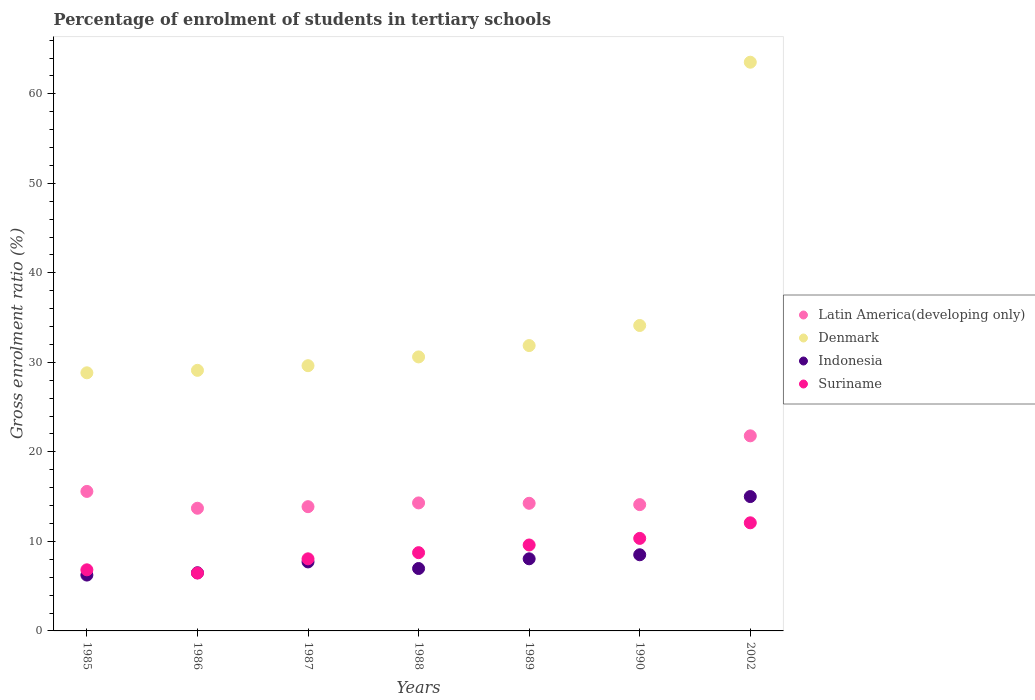Is the number of dotlines equal to the number of legend labels?
Offer a very short reply. Yes. What is the percentage of students enrolled in tertiary schools in Indonesia in 1989?
Provide a succinct answer. 8.06. Across all years, what is the maximum percentage of students enrolled in tertiary schools in Latin America(developing only)?
Your answer should be very brief. 21.8. Across all years, what is the minimum percentage of students enrolled in tertiary schools in Latin America(developing only)?
Your response must be concise. 13.71. What is the total percentage of students enrolled in tertiary schools in Indonesia in the graph?
Provide a short and direct response. 58.99. What is the difference between the percentage of students enrolled in tertiary schools in Suriname in 1986 and that in 1989?
Make the answer very short. -3.13. What is the difference between the percentage of students enrolled in tertiary schools in Denmark in 1989 and the percentage of students enrolled in tertiary schools in Suriname in 1986?
Provide a short and direct response. 25.41. What is the average percentage of students enrolled in tertiary schools in Latin America(developing only) per year?
Provide a succinct answer. 15.38. In the year 1985, what is the difference between the percentage of students enrolled in tertiary schools in Suriname and percentage of students enrolled in tertiary schools in Latin America(developing only)?
Keep it short and to the point. -8.76. In how many years, is the percentage of students enrolled in tertiary schools in Latin America(developing only) greater than 8 %?
Make the answer very short. 7. What is the ratio of the percentage of students enrolled in tertiary schools in Latin America(developing only) in 1987 to that in 1990?
Offer a very short reply. 0.98. Is the percentage of students enrolled in tertiary schools in Denmark in 1987 less than that in 1988?
Your response must be concise. Yes. Is the difference between the percentage of students enrolled in tertiary schools in Suriname in 1987 and 1989 greater than the difference between the percentage of students enrolled in tertiary schools in Latin America(developing only) in 1987 and 1989?
Your response must be concise. No. What is the difference between the highest and the second highest percentage of students enrolled in tertiary schools in Denmark?
Your answer should be compact. 29.41. What is the difference between the highest and the lowest percentage of students enrolled in tertiary schools in Suriname?
Make the answer very short. 5.61. In how many years, is the percentage of students enrolled in tertiary schools in Indonesia greater than the average percentage of students enrolled in tertiary schools in Indonesia taken over all years?
Your response must be concise. 2. Is the sum of the percentage of students enrolled in tertiary schools in Suriname in 1987 and 2002 greater than the maximum percentage of students enrolled in tertiary schools in Denmark across all years?
Provide a succinct answer. No. How many dotlines are there?
Offer a very short reply. 4. Does the graph contain any zero values?
Give a very brief answer. No. Does the graph contain grids?
Offer a terse response. No. How are the legend labels stacked?
Give a very brief answer. Vertical. What is the title of the graph?
Provide a short and direct response. Percentage of enrolment of students in tertiary schools. Does "Palau" appear as one of the legend labels in the graph?
Provide a short and direct response. No. What is the label or title of the X-axis?
Your answer should be very brief. Years. What is the Gross enrolment ratio (%) in Latin America(developing only) in 1985?
Keep it short and to the point. 15.59. What is the Gross enrolment ratio (%) of Denmark in 1985?
Make the answer very short. 28.84. What is the Gross enrolment ratio (%) of Indonesia in 1985?
Make the answer very short. 6.24. What is the Gross enrolment ratio (%) of Suriname in 1985?
Provide a short and direct response. 6.83. What is the Gross enrolment ratio (%) of Latin America(developing only) in 1986?
Offer a very short reply. 13.71. What is the Gross enrolment ratio (%) in Denmark in 1986?
Offer a terse response. 29.11. What is the Gross enrolment ratio (%) in Indonesia in 1986?
Offer a terse response. 6.5. What is the Gross enrolment ratio (%) of Suriname in 1986?
Your answer should be very brief. 6.47. What is the Gross enrolment ratio (%) in Latin America(developing only) in 1987?
Provide a short and direct response. 13.88. What is the Gross enrolment ratio (%) in Denmark in 1987?
Your answer should be compact. 29.63. What is the Gross enrolment ratio (%) in Indonesia in 1987?
Your answer should be compact. 7.71. What is the Gross enrolment ratio (%) of Suriname in 1987?
Your answer should be very brief. 8.05. What is the Gross enrolment ratio (%) in Latin America(developing only) in 1988?
Make the answer very short. 14.3. What is the Gross enrolment ratio (%) in Denmark in 1988?
Make the answer very short. 30.61. What is the Gross enrolment ratio (%) of Indonesia in 1988?
Offer a very short reply. 6.97. What is the Gross enrolment ratio (%) in Suriname in 1988?
Your answer should be very brief. 8.74. What is the Gross enrolment ratio (%) in Latin America(developing only) in 1989?
Provide a succinct answer. 14.26. What is the Gross enrolment ratio (%) of Denmark in 1989?
Make the answer very short. 31.88. What is the Gross enrolment ratio (%) in Indonesia in 1989?
Offer a very short reply. 8.06. What is the Gross enrolment ratio (%) in Suriname in 1989?
Ensure brevity in your answer.  9.6. What is the Gross enrolment ratio (%) of Latin America(developing only) in 1990?
Give a very brief answer. 14.11. What is the Gross enrolment ratio (%) in Denmark in 1990?
Offer a very short reply. 34.12. What is the Gross enrolment ratio (%) of Indonesia in 1990?
Your answer should be very brief. 8.51. What is the Gross enrolment ratio (%) in Suriname in 1990?
Provide a short and direct response. 10.34. What is the Gross enrolment ratio (%) in Latin America(developing only) in 2002?
Your answer should be very brief. 21.8. What is the Gross enrolment ratio (%) in Denmark in 2002?
Your answer should be very brief. 63.54. What is the Gross enrolment ratio (%) of Indonesia in 2002?
Your answer should be compact. 15.01. What is the Gross enrolment ratio (%) in Suriname in 2002?
Offer a terse response. 12.08. Across all years, what is the maximum Gross enrolment ratio (%) of Latin America(developing only)?
Your answer should be very brief. 21.8. Across all years, what is the maximum Gross enrolment ratio (%) in Denmark?
Your response must be concise. 63.54. Across all years, what is the maximum Gross enrolment ratio (%) of Indonesia?
Make the answer very short. 15.01. Across all years, what is the maximum Gross enrolment ratio (%) of Suriname?
Your response must be concise. 12.08. Across all years, what is the minimum Gross enrolment ratio (%) in Latin America(developing only)?
Offer a terse response. 13.71. Across all years, what is the minimum Gross enrolment ratio (%) of Denmark?
Your response must be concise. 28.84. Across all years, what is the minimum Gross enrolment ratio (%) of Indonesia?
Your answer should be very brief. 6.24. Across all years, what is the minimum Gross enrolment ratio (%) in Suriname?
Make the answer very short. 6.47. What is the total Gross enrolment ratio (%) of Latin America(developing only) in the graph?
Make the answer very short. 107.64. What is the total Gross enrolment ratio (%) in Denmark in the graph?
Your answer should be very brief. 247.73. What is the total Gross enrolment ratio (%) of Indonesia in the graph?
Your response must be concise. 58.99. What is the total Gross enrolment ratio (%) of Suriname in the graph?
Give a very brief answer. 62.11. What is the difference between the Gross enrolment ratio (%) of Latin America(developing only) in 1985 and that in 1986?
Provide a short and direct response. 1.88. What is the difference between the Gross enrolment ratio (%) in Denmark in 1985 and that in 1986?
Your response must be concise. -0.28. What is the difference between the Gross enrolment ratio (%) in Indonesia in 1985 and that in 1986?
Provide a succinct answer. -0.26. What is the difference between the Gross enrolment ratio (%) of Suriname in 1985 and that in 1986?
Your answer should be very brief. 0.36. What is the difference between the Gross enrolment ratio (%) in Latin America(developing only) in 1985 and that in 1987?
Ensure brevity in your answer.  1.71. What is the difference between the Gross enrolment ratio (%) of Denmark in 1985 and that in 1987?
Your answer should be very brief. -0.8. What is the difference between the Gross enrolment ratio (%) of Indonesia in 1985 and that in 1987?
Your response must be concise. -1.47. What is the difference between the Gross enrolment ratio (%) in Suriname in 1985 and that in 1987?
Make the answer very short. -1.23. What is the difference between the Gross enrolment ratio (%) in Latin America(developing only) in 1985 and that in 1988?
Keep it short and to the point. 1.28. What is the difference between the Gross enrolment ratio (%) in Denmark in 1985 and that in 1988?
Provide a succinct answer. -1.78. What is the difference between the Gross enrolment ratio (%) in Indonesia in 1985 and that in 1988?
Provide a succinct answer. -0.73. What is the difference between the Gross enrolment ratio (%) in Suriname in 1985 and that in 1988?
Make the answer very short. -1.92. What is the difference between the Gross enrolment ratio (%) of Latin America(developing only) in 1985 and that in 1989?
Make the answer very short. 1.33. What is the difference between the Gross enrolment ratio (%) of Denmark in 1985 and that in 1989?
Provide a short and direct response. -3.04. What is the difference between the Gross enrolment ratio (%) in Indonesia in 1985 and that in 1989?
Offer a terse response. -1.82. What is the difference between the Gross enrolment ratio (%) of Suriname in 1985 and that in 1989?
Ensure brevity in your answer.  -2.77. What is the difference between the Gross enrolment ratio (%) in Latin America(developing only) in 1985 and that in 1990?
Give a very brief answer. 1.48. What is the difference between the Gross enrolment ratio (%) of Denmark in 1985 and that in 1990?
Keep it short and to the point. -5.29. What is the difference between the Gross enrolment ratio (%) of Indonesia in 1985 and that in 1990?
Ensure brevity in your answer.  -2.27. What is the difference between the Gross enrolment ratio (%) of Suriname in 1985 and that in 1990?
Offer a very short reply. -3.51. What is the difference between the Gross enrolment ratio (%) of Latin America(developing only) in 1985 and that in 2002?
Ensure brevity in your answer.  -6.21. What is the difference between the Gross enrolment ratio (%) in Denmark in 1985 and that in 2002?
Give a very brief answer. -34.7. What is the difference between the Gross enrolment ratio (%) in Indonesia in 1985 and that in 2002?
Provide a short and direct response. -8.77. What is the difference between the Gross enrolment ratio (%) of Suriname in 1985 and that in 2002?
Your response must be concise. -5.25. What is the difference between the Gross enrolment ratio (%) in Latin America(developing only) in 1986 and that in 1987?
Ensure brevity in your answer.  -0.17. What is the difference between the Gross enrolment ratio (%) of Denmark in 1986 and that in 1987?
Provide a succinct answer. -0.52. What is the difference between the Gross enrolment ratio (%) in Indonesia in 1986 and that in 1987?
Offer a terse response. -1.21. What is the difference between the Gross enrolment ratio (%) in Suriname in 1986 and that in 1987?
Your answer should be compact. -1.59. What is the difference between the Gross enrolment ratio (%) of Latin America(developing only) in 1986 and that in 1988?
Your answer should be very brief. -0.6. What is the difference between the Gross enrolment ratio (%) of Denmark in 1986 and that in 1988?
Your answer should be very brief. -1.5. What is the difference between the Gross enrolment ratio (%) in Indonesia in 1986 and that in 1988?
Ensure brevity in your answer.  -0.48. What is the difference between the Gross enrolment ratio (%) in Suriname in 1986 and that in 1988?
Ensure brevity in your answer.  -2.28. What is the difference between the Gross enrolment ratio (%) of Latin America(developing only) in 1986 and that in 1989?
Your response must be concise. -0.55. What is the difference between the Gross enrolment ratio (%) of Denmark in 1986 and that in 1989?
Keep it short and to the point. -2.77. What is the difference between the Gross enrolment ratio (%) in Indonesia in 1986 and that in 1989?
Ensure brevity in your answer.  -1.56. What is the difference between the Gross enrolment ratio (%) of Suriname in 1986 and that in 1989?
Provide a succinct answer. -3.13. What is the difference between the Gross enrolment ratio (%) in Latin America(developing only) in 1986 and that in 1990?
Provide a short and direct response. -0.4. What is the difference between the Gross enrolment ratio (%) of Denmark in 1986 and that in 1990?
Your answer should be very brief. -5.01. What is the difference between the Gross enrolment ratio (%) of Indonesia in 1986 and that in 1990?
Offer a terse response. -2.01. What is the difference between the Gross enrolment ratio (%) in Suriname in 1986 and that in 1990?
Make the answer very short. -3.87. What is the difference between the Gross enrolment ratio (%) in Latin America(developing only) in 1986 and that in 2002?
Give a very brief answer. -8.09. What is the difference between the Gross enrolment ratio (%) in Denmark in 1986 and that in 2002?
Your answer should be compact. -34.42. What is the difference between the Gross enrolment ratio (%) in Indonesia in 1986 and that in 2002?
Provide a succinct answer. -8.51. What is the difference between the Gross enrolment ratio (%) of Suriname in 1986 and that in 2002?
Offer a very short reply. -5.61. What is the difference between the Gross enrolment ratio (%) in Latin America(developing only) in 1987 and that in 1988?
Provide a succinct answer. -0.42. What is the difference between the Gross enrolment ratio (%) in Denmark in 1987 and that in 1988?
Give a very brief answer. -0.98. What is the difference between the Gross enrolment ratio (%) of Indonesia in 1987 and that in 1988?
Provide a short and direct response. 0.74. What is the difference between the Gross enrolment ratio (%) of Suriname in 1987 and that in 1988?
Offer a very short reply. -0.69. What is the difference between the Gross enrolment ratio (%) in Latin America(developing only) in 1987 and that in 1989?
Provide a succinct answer. -0.38. What is the difference between the Gross enrolment ratio (%) in Denmark in 1987 and that in 1989?
Your response must be concise. -2.25. What is the difference between the Gross enrolment ratio (%) in Indonesia in 1987 and that in 1989?
Your response must be concise. -0.35. What is the difference between the Gross enrolment ratio (%) in Suriname in 1987 and that in 1989?
Your answer should be very brief. -1.55. What is the difference between the Gross enrolment ratio (%) in Latin America(developing only) in 1987 and that in 1990?
Offer a very short reply. -0.23. What is the difference between the Gross enrolment ratio (%) of Denmark in 1987 and that in 1990?
Offer a very short reply. -4.49. What is the difference between the Gross enrolment ratio (%) in Indonesia in 1987 and that in 1990?
Provide a succinct answer. -0.8. What is the difference between the Gross enrolment ratio (%) in Suriname in 1987 and that in 1990?
Your answer should be very brief. -2.28. What is the difference between the Gross enrolment ratio (%) in Latin America(developing only) in 1987 and that in 2002?
Give a very brief answer. -7.92. What is the difference between the Gross enrolment ratio (%) in Denmark in 1987 and that in 2002?
Ensure brevity in your answer.  -33.9. What is the difference between the Gross enrolment ratio (%) of Indonesia in 1987 and that in 2002?
Offer a terse response. -7.3. What is the difference between the Gross enrolment ratio (%) in Suriname in 1987 and that in 2002?
Your response must be concise. -4.02. What is the difference between the Gross enrolment ratio (%) of Latin America(developing only) in 1988 and that in 1989?
Make the answer very short. 0.04. What is the difference between the Gross enrolment ratio (%) in Denmark in 1988 and that in 1989?
Provide a succinct answer. -1.27. What is the difference between the Gross enrolment ratio (%) in Indonesia in 1988 and that in 1989?
Offer a terse response. -1.08. What is the difference between the Gross enrolment ratio (%) of Suriname in 1988 and that in 1989?
Make the answer very short. -0.86. What is the difference between the Gross enrolment ratio (%) of Latin America(developing only) in 1988 and that in 1990?
Provide a succinct answer. 0.19. What is the difference between the Gross enrolment ratio (%) in Denmark in 1988 and that in 1990?
Make the answer very short. -3.51. What is the difference between the Gross enrolment ratio (%) in Indonesia in 1988 and that in 1990?
Ensure brevity in your answer.  -1.53. What is the difference between the Gross enrolment ratio (%) of Suriname in 1988 and that in 1990?
Provide a succinct answer. -1.6. What is the difference between the Gross enrolment ratio (%) of Latin America(developing only) in 1988 and that in 2002?
Your response must be concise. -7.49. What is the difference between the Gross enrolment ratio (%) of Denmark in 1988 and that in 2002?
Ensure brevity in your answer.  -32.92. What is the difference between the Gross enrolment ratio (%) of Indonesia in 1988 and that in 2002?
Keep it short and to the point. -8.04. What is the difference between the Gross enrolment ratio (%) of Suriname in 1988 and that in 2002?
Offer a very short reply. -3.34. What is the difference between the Gross enrolment ratio (%) of Latin America(developing only) in 1989 and that in 1990?
Give a very brief answer. 0.15. What is the difference between the Gross enrolment ratio (%) in Denmark in 1989 and that in 1990?
Make the answer very short. -2.24. What is the difference between the Gross enrolment ratio (%) in Indonesia in 1989 and that in 1990?
Ensure brevity in your answer.  -0.45. What is the difference between the Gross enrolment ratio (%) in Suriname in 1989 and that in 1990?
Your response must be concise. -0.74. What is the difference between the Gross enrolment ratio (%) in Latin America(developing only) in 1989 and that in 2002?
Keep it short and to the point. -7.54. What is the difference between the Gross enrolment ratio (%) in Denmark in 1989 and that in 2002?
Your response must be concise. -31.66. What is the difference between the Gross enrolment ratio (%) in Indonesia in 1989 and that in 2002?
Keep it short and to the point. -6.95. What is the difference between the Gross enrolment ratio (%) of Suriname in 1989 and that in 2002?
Make the answer very short. -2.48. What is the difference between the Gross enrolment ratio (%) of Latin America(developing only) in 1990 and that in 2002?
Offer a terse response. -7.69. What is the difference between the Gross enrolment ratio (%) of Denmark in 1990 and that in 2002?
Offer a terse response. -29.41. What is the difference between the Gross enrolment ratio (%) of Indonesia in 1990 and that in 2002?
Your response must be concise. -6.5. What is the difference between the Gross enrolment ratio (%) of Suriname in 1990 and that in 2002?
Your response must be concise. -1.74. What is the difference between the Gross enrolment ratio (%) of Latin America(developing only) in 1985 and the Gross enrolment ratio (%) of Denmark in 1986?
Make the answer very short. -13.53. What is the difference between the Gross enrolment ratio (%) of Latin America(developing only) in 1985 and the Gross enrolment ratio (%) of Indonesia in 1986?
Your answer should be compact. 9.09. What is the difference between the Gross enrolment ratio (%) in Latin America(developing only) in 1985 and the Gross enrolment ratio (%) in Suriname in 1986?
Offer a terse response. 9.12. What is the difference between the Gross enrolment ratio (%) in Denmark in 1985 and the Gross enrolment ratio (%) in Indonesia in 1986?
Provide a succinct answer. 22.34. What is the difference between the Gross enrolment ratio (%) of Denmark in 1985 and the Gross enrolment ratio (%) of Suriname in 1986?
Your answer should be very brief. 22.37. What is the difference between the Gross enrolment ratio (%) of Indonesia in 1985 and the Gross enrolment ratio (%) of Suriname in 1986?
Make the answer very short. -0.23. What is the difference between the Gross enrolment ratio (%) in Latin America(developing only) in 1985 and the Gross enrolment ratio (%) in Denmark in 1987?
Your response must be concise. -14.05. What is the difference between the Gross enrolment ratio (%) of Latin America(developing only) in 1985 and the Gross enrolment ratio (%) of Indonesia in 1987?
Provide a succinct answer. 7.88. What is the difference between the Gross enrolment ratio (%) of Latin America(developing only) in 1985 and the Gross enrolment ratio (%) of Suriname in 1987?
Provide a short and direct response. 7.53. What is the difference between the Gross enrolment ratio (%) of Denmark in 1985 and the Gross enrolment ratio (%) of Indonesia in 1987?
Provide a short and direct response. 21.13. What is the difference between the Gross enrolment ratio (%) of Denmark in 1985 and the Gross enrolment ratio (%) of Suriname in 1987?
Your response must be concise. 20.78. What is the difference between the Gross enrolment ratio (%) in Indonesia in 1985 and the Gross enrolment ratio (%) in Suriname in 1987?
Ensure brevity in your answer.  -1.81. What is the difference between the Gross enrolment ratio (%) of Latin America(developing only) in 1985 and the Gross enrolment ratio (%) of Denmark in 1988?
Offer a terse response. -15.03. What is the difference between the Gross enrolment ratio (%) of Latin America(developing only) in 1985 and the Gross enrolment ratio (%) of Indonesia in 1988?
Ensure brevity in your answer.  8.61. What is the difference between the Gross enrolment ratio (%) in Latin America(developing only) in 1985 and the Gross enrolment ratio (%) in Suriname in 1988?
Provide a short and direct response. 6.84. What is the difference between the Gross enrolment ratio (%) of Denmark in 1985 and the Gross enrolment ratio (%) of Indonesia in 1988?
Your answer should be very brief. 21.86. What is the difference between the Gross enrolment ratio (%) of Denmark in 1985 and the Gross enrolment ratio (%) of Suriname in 1988?
Your answer should be very brief. 20.09. What is the difference between the Gross enrolment ratio (%) of Indonesia in 1985 and the Gross enrolment ratio (%) of Suriname in 1988?
Your answer should be very brief. -2.5. What is the difference between the Gross enrolment ratio (%) in Latin America(developing only) in 1985 and the Gross enrolment ratio (%) in Denmark in 1989?
Offer a terse response. -16.29. What is the difference between the Gross enrolment ratio (%) in Latin America(developing only) in 1985 and the Gross enrolment ratio (%) in Indonesia in 1989?
Keep it short and to the point. 7.53. What is the difference between the Gross enrolment ratio (%) in Latin America(developing only) in 1985 and the Gross enrolment ratio (%) in Suriname in 1989?
Make the answer very short. 5.98. What is the difference between the Gross enrolment ratio (%) in Denmark in 1985 and the Gross enrolment ratio (%) in Indonesia in 1989?
Your answer should be compact. 20.78. What is the difference between the Gross enrolment ratio (%) in Denmark in 1985 and the Gross enrolment ratio (%) in Suriname in 1989?
Your answer should be compact. 19.24. What is the difference between the Gross enrolment ratio (%) in Indonesia in 1985 and the Gross enrolment ratio (%) in Suriname in 1989?
Ensure brevity in your answer.  -3.36. What is the difference between the Gross enrolment ratio (%) in Latin America(developing only) in 1985 and the Gross enrolment ratio (%) in Denmark in 1990?
Your answer should be very brief. -18.54. What is the difference between the Gross enrolment ratio (%) of Latin America(developing only) in 1985 and the Gross enrolment ratio (%) of Indonesia in 1990?
Offer a terse response. 7.08. What is the difference between the Gross enrolment ratio (%) in Latin America(developing only) in 1985 and the Gross enrolment ratio (%) in Suriname in 1990?
Provide a short and direct response. 5.25. What is the difference between the Gross enrolment ratio (%) of Denmark in 1985 and the Gross enrolment ratio (%) of Indonesia in 1990?
Give a very brief answer. 20.33. What is the difference between the Gross enrolment ratio (%) of Denmark in 1985 and the Gross enrolment ratio (%) of Suriname in 1990?
Offer a very short reply. 18.5. What is the difference between the Gross enrolment ratio (%) of Indonesia in 1985 and the Gross enrolment ratio (%) of Suriname in 1990?
Your response must be concise. -4.1. What is the difference between the Gross enrolment ratio (%) in Latin America(developing only) in 1985 and the Gross enrolment ratio (%) in Denmark in 2002?
Make the answer very short. -47.95. What is the difference between the Gross enrolment ratio (%) of Latin America(developing only) in 1985 and the Gross enrolment ratio (%) of Indonesia in 2002?
Your response must be concise. 0.58. What is the difference between the Gross enrolment ratio (%) of Latin America(developing only) in 1985 and the Gross enrolment ratio (%) of Suriname in 2002?
Your answer should be very brief. 3.51. What is the difference between the Gross enrolment ratio (%) in Denmark in 1985 and the Gross enrolment ratio (%) in Indonesia in 2002?
Ensure brevity in your answer.  13.83. What is the difference between the Gross enrolment ratio (%) of Denmark in 1985 and the Gross enrolment ratio (%) of Suriname in 2002?
Your answer should be very brief. 16.76. What is the difference between the Gross enrolment ratio (%) of Indonesia in 1985 and the Gross enrolment ratio (%) of Suriname in 2002?
Provide a short and direct response. -5.84. What is the difference between the Gross enrolment ratio (%) of Latin America(developing only) in 1986 and the Gross enrolment ratio (%) of Denmark in 1987?
Your response must be concise. -15.93. What is the difference between the Gross enrolment ratio (%) of Latin America(developing only) in 1986 and the Gross enrolment ratio (%) of Indonesia in 1987?
Your response must be concise. 6. What is the difference between the Gross enrolment ratio (%) in Latin America(developing only) in 1986 and the Gross enrolment ratio (%) in Suriname in 1987?
Provide a succinct answer. 5.65. What is the difference between the Gross enrolment ratio (%) in Denmark in 1986 and the Gross enrolment ratio (%) in Indonesia in 1987?
Your answer should be compact. 21.4. What is the difference between the Gross enrolment ratio (%) of Denmark in 1986 and the Gross enrolment ratio (%) of Suriname in 1987?
Provide a short and direct response. 21.06. What is the difference between the Gross enrolment ratio (%) in Indonesia in 1986 and the Gross enrolment ratio (%) in Suriname in 1987?
Make the answer very short. -1.56. What is the difference between the Gross enrolment ratio (%) in Latin America(developing only) in 1986 and the Gross enrolment ratio (%) in Denmark in 1988?
Ensure brevity in your answer.  -16.91. What is the difference between the Gross enrolment ratio (%) in Latin America(developing only) in 1986 and the Gross enrolment ratio (%) in Indonesia in 1988?
Your answer should be compact. 6.73. What is the difference between the Gross enrolment ratio (%) in Latin America(developing only) in 1986 and the Gross enrolment ratio (%) in Suriname in 1988?
Offer a terse response. 4.96. What is the difference between the Gross enrolment ratio (%) of Denmark in 1986 and the Gross enrolment ratio (%) of Indonesia in 1988?
Your answer should be very brief. 22.14. What is the difference between the Gross enrolment ratio (%) in Denmark in 1986 and the Gross enrolment ratio (%) in Suriname in 1988?
Your answer should be very brief. 20.37. What is the difference between the Gross enrolment ratio (%) in Indonesia in 1986 and the Gross enrolment ratio (%) in Suriname in 1988?
Provide a short and direct response. -2.25. What is the difference between the Gross enrolment ratio (%) in Latin America(developing only) in 1986 and the Gross enrolment ratio (%) in Denmark in 1989?
Your answer should be compact. -18.17. What is the difference between the Gross enrolment ratio (%) of Latin America(developing only) in 1986 and the Gross enrolment ratio (%) of Indonesia in 1989?
Ensure brevity in your answer.  5.65. What is the difference between the Gross enrolment ratio (%) in Latin America(developing only) in 1986 and the Gross enrolment ratio (%) in Suriname in 1989?
Provide a succinct answer. 4.11. What is the difference between the Gross enrolment ratio (%) of Denmark in 1986 and the Gross enrolment ratio (%) of Indonesia in 1989?
Your answer should be compact. 21.06. What is the difference between the Gross enrolment ratio (%) in Denmark in 1986 and the Gross enrolment ratio (%) in Suriname in 1989?
Your response must be concise. 19.51. What is the difference between the Gross enrolment ratio (%) of Indonesia in 1986 and the Gross enrolment ratio (%) of Suriname in 1989?
Offer a terse response. -3.1. What is the difference between the Gross enrolment ratio (%) of Latin America(developing only) in 1986 and the Gross enrolment ratio (%) of Denmark in 1990?
Your answer should be compact. -20.42. What is the difference between the Gross enrolment ratio (%) in Latin America(developing only) in 1986 and the Gross enrolment ratio (%) in Indonesia in 1990?
Give a very brief answer. 5.2. What is the difference between the Gross enrolment ratio (%) of Latin America(developing only) in 1986 and the Gross enrolment ratio (%) of Suriname in 1990?
Make the answer very short. 3.37. What is the difference between the Gross enrolment ratio (%) in Denmark in 1986 and the Gross enrolment ratio (%) in Indonesia in 1990?
Your answer should be very brief. 20.6. What is the difference between the Gross enrolment ratio (%) in Denmark in 1986 and the Gross enrolment ratio (%) in Suriname in 1990?
Ensure brevity in your answer.  18.77. What is the difference between the Gross enrolment ratio (%) of Indonesia in 1986 and the Gross enrolment ratio (%) of Suriname in 1990?
Make the answer very short. -3.84. What is the difference between the Gross enrolment ratio (%) of Latin America(developing only) in 1986 and the Gross enrolment ratio (%) of Denmark in 2002?
Your answer should be very brief. -49.83. What is the difference between the Gross enrolment ratio (%) in Latin America(developing only) in 1986 and the Gross enrolment ratio (%) in Indonesia in 2002?
Give a very brief answer. -1.3. What is the difference between the Gross enrolment ratio (%) of Latin America(developing only) in 1986 and the Gross enrolment ratio (%) of Suriname in 2002?
Ensure brevity in your answer.  1.63. What is the difference between the Gross enrolment ratio (%) of Denmark in 1986 and the Gross enrolment ratio (%) of Indonesia in 2002?
Your answer should be very brief. 14.1. What is the difference between the Gross enrolment ratio (%) in Denmark in 1986 and the Gross enrolment ratio (%) in Suriname in 2002?
Your answer should be very brief. 17.03. What is the difference between the Gross enrolment ratio (%) in Indonesia in 1986 and the Gross enrolment ratio (%) in Suriname in 2002?
Offer a very short reply. -5.58. What is the difference between the Gross enrolment ratio (%) in Latin America(developing only) in 1987 and the Gross enrolment ratio (%) in Denmark in 1988?
Keep it short and to the point. -16.73. What is the difference between the Gross enrolment ratio (%) of Latin America(developing only) in 1987 and the Gross enrolment ratio (%) of Indonesia in 1988?
Keep it short and to the point. 6.91. What is the difference between the Gross enrolment ratio (%) in Latin America(developing only) in 1987 and the Gross enrolment ratio (%) in Suriname in 1988?
Provide a succinct answer. 5.14. What is the difference between the Gross enrolment ratio (%) of Denmark in 1987 and the Gross enrolment ratio (%) of Indonesia in 1988?
Give a very brief answer. 22.66. What is the difference between the Gross enrolment ratio (%) in Denmark in 1987 and the Gross enrolment ratio (%) in Suriname in 1988?
Your response must be concise. 20.89. What is the difference between the Gross enrolment ratio (%) of Indonesia in 1987 and the Gross enrolment ratio (%) of Suriname in 1988?
Your answer should be very brief. -1.03. What is the difference between the Gross enrolment ratio (%) in Latin America(developing only) in 1987 and the Gross enrolment ratio (%) in Denmark in 1989?
Give a very brief answer. -18. What is the difference between the Gross enrolment ratio (%) in Latin America(developing only) in 1987 and the Gross enrolment ratio (%) in Indonesia in 1989?
Ensure brevity in your answer.  5.82. What is the difference between the Gross enrolment ratio (%) in Latin America(developing only) in 1987 and the Gross enrolment ratio (%) in Suriname in 1989?
Your answer should be very brief. 4.28. What is the difference between the Gross enrolment ratio (%) in Denmark in 1987 and the Gross enrolment ratio (%) in Indonesia in 1989?
Provide a succinct answer. 21.58. What is the difference between the Gross enrolment ratio (%) in Denmark in 1987 and the Gross enrolment ratio (%) in Suriname in 1989?
Your answer should be very brief. 20.03. What is the difference between the Gross enrolment ratio (%) of Indonesia in 1987 and the Gross enrolment ratio (%) of Suriname in 1989?
Ensure brevity in your answer.  -1.89. What is the difference between the Gross enrolment ratio (%) of Latin America(developing only) in 1987 and the Gross enrolment ratio (%) of Denmark in 1990?
Your answer should be compact. -20.24. What is the difference between the Gross enrolment ratio (%) in Latin America(developing only) in 1987 and the Gross enrolment ratio (%) in Indonesia in 1990?
Offer a terse response. 5.37. What is the difference between the Gross enrolment ratio (%) in Latin America(developing only) in 1987 and the Gross enrolment ratio (%) in Suriname in 1990?
Ensure brevity in your answer.  3.54. What is the difference between the Gross enrolment ratio (%) of Denmark in 1987 and the Gross enrolment ratio (%) of Indonesia in 1990?
Offer a terse response. 21.12. What is the difference between the Gross enrolment ratio (%) in Denmark in 1987 and the Gross enrolment ratio (%) in Suriname in 1990?
Keep it short and to the point. 19.29. What is the difference between the Gross enrolment ratio (%) in Indonesia in 1987 and the Gross enrolment ratio (%) in Suriname in 1990?
Your response must be concise. -2.63. What is the difference between the Gross enrolment ratio (%) in Latin America(developing only) in 1987 and the Gross enrolment ratio (%) in Denmark in 2002?
Provide a short and direct response. -49.65. What is the difference between the Gross enrolment ratio (%) in Latin America(developing only) in 1987 and the Gross enrolment ratio (%) in Indonesia in 2002?
Your answer should be very brief. -1.13. What is the difference between the Gross enrolment ratio (%) in Latin America(developing only) in 1987 and the Gross enrolment ratio (%) in Suriname in 2002?
Keep it short and to the point. 1.8. What is the difference between the Gross enrolment ratio (%) in Denmark in 1987 and the Gross enrolment ratio (%) in Indonesia in 2002?
Provide a succinct answer. 14.62. What is the difference between the Gross enrolment ratio (%) in Denmark in 1987 and the Gross enrolment ratio (%) in Suriname in 2002?
Give a very brief answer. 17.55. What is the difference between the Gross enrolment ratio (%) of Indonesia in 1987 and the Gross enrolment ratio (%) of Suriname in 2002?
Your answer should be very brief. -4.37. What is the difference between the Gross enrolment ratio (%) in Latin America(developing only) in 1988 and the Gross enrolment ratio (%) in Denmark in 1989?
Provide a succinct answer. -17.58. What is the difference between the Gross enrolment ratio (%) in Latin America(developing only) in 1988 and the Gross enrolment ratio (%) in Indonesia in 1989?
Ensure brevity in your answer.  6.25. What is the difference between the Gross enrolment ratio (%) of Latin America(developing only) in 1988 and the Gross enrolment ratio (%) of Suriname in 1989?
Offer a terse response. 4.7. What is the difference between the Gross enrolment ratio (%) in Denmark in 1988 and the Gross enrolment ratio (%) in Indonesia in 1989?
Offer a terse response. 22.56. What is the difference between the Gross enrolment ratio (%) in Denmark in 1988 and the Gross enrolment ratio (%) in Suriname in 1989?
Provide a short and direct response. 21.01. What is the difference between the Gross enrolment ratio (%) of Indonesia in 1988 and the Gross enrolment ratio (%) of Suriname in 1989?
Your answer should be very brief. -2.63. What is the difference between the Gross enrolment ratio (%) of Latin America(developing only) in 1988 and the Gross enrolment ratio (%) of Denmark in 1990?
Provide a short and direct response. -19.82. What is the difference between the Gross enrolment ratio (%) of Latin America(developing only) in 1988 and the Gross enrolment ratio (%) of Indonesia in 1990?
Provide a succinct answer. 5.79. What is the difference between the Gross enrolment ratio (%) in Latin America(developing only) in 1988 and the Gross enrolment ratio (%) in Suriname in 1990?
Ensure brevity in your answer.  3.96. What is the difference between the Gross enrolment ratio (%) of Denmark in 1988 and the Gross enrolment ratio (%) of Indonesia in 1990?
Provide a succinct answer. 22.11. What is the difference between the Gross enrolment ratio (%) in Denmark in 1988 and the Gross enrolment ratio (%) in Suriname in 1990?
Make the answer very short. 20.27. What is the difference between the Gross enrolment ratio (%) in Indonesia in 1988 and the Gross enrolment ratio (%) in Suriname in 1990?
Offer a terse response. -3.37. What is the difference between the Gross enrolment ratio (%) of Latin America(developing only) in 1988 and the Gross enrolment ratio (%) of Denmark in 2002?
Provide a succinct answer. -49.23. What is the difference between the Gross enrolment ratio (%) of Latin America(developing only) in 1988 and the Gross enrolment ratio (%) of Indonesia in 2002?
Your answer should be compact. -0.71. What is the difference between the Gross enrolment ratio (%) of Latin America(developing only) in 1988 and the Gross enrolment ratio (%) of Suriname in 2002?
Provide a succinct answer. 2.22. What is the difference between the Gross enrolment ratio (%) in Denmark in 1988 and the Gross enrolment ratio (%) in Indonesia in 2002?
Your response must be concise. 15.6. What is the difference between the Gross enrolment ratio (%) in Denmark in 1988 and the Gross enrolment ratio (%) in Suriname in 2002?
Offer a terse response. 18.53. What is the difference between the Gross enrolment ratio (%) in Indonesia in 1988 and the Gross enrolment ratio (%) in Suriname in 2002?
Your answer should be very brief. -5.11. What is the difference between the Gross enrolment ratio (%) of Latin America(developing only) in 1989 and the Gross enrolment ratio (%) of Denmark in 1990?
Give a very brief answer. -19.86. What is the difference between the Gross enrolment ratio (%) in Latin America(developing only) in 1989 and the Gross enrolment ratio (%) in Indonesia in 1990?
Offer a terse response. 5.75. What is the difference between the Gross enrolment ratio (%) of Latin America(developing only) in 1989 and the Gross enrolment ratio (%) of Suriname in 1990?
Ensure brevity in your answer.  3.92. What is the difference between the Gross enrolment ratio (%) in Denmark in 1989 and the Gross enrolment ratio (%) in Indonesia in 1990?
Your answer should be compact. 23.37. What is the difference between the Gross enrolment ratio (%) of Denmark in 1989 and the Gross enrolment ratio (%) of Suriname in 1990?
Keep it short and to the point. 21.54. What is the difference between the Gross enrolment ratio (%) in Indonesia in 1989 and the Gross enrolment ratio (%) in Suriname in 1990?
Your answer should be compact. -2.28. What is the difference between the Gross enrolment ratio (%) of Latin America(developing only) in 1989 and the Gross enrolment ratio (%) of Denmark in 2002?
Make the answer very short. -49.28. What is the difference between the Gross enrolment ratio (%) in Latin America(developing only) in 1989 and the Gross enrolment ratio (%) in Indonesia in 2002?
Offer a very short reply. -0.75. What is the difference between the Gross enrolment ratio (%) of Latin America(developing only) in 1989 and the Gross enrolment ratio (%) of Suriname in 2002?
Provide a succinct answer. 2.18. What is the difference between the Gross enrolment ratio (%) of Denmark in 1989 and the Gross enrolment ratio (%) of Indonesia in 2002?
Make the answer very short. 16.87. What is the difference between the Gross enrolment ratio (%) of Denmark in 1989 and the Gross enrolment ratio (%) of Suriname in 2002?
Give a very brief answer. 19.8. What is the difference between the Gross enrolment ratio (%) in Indonesia in 1989 and the Gross enrolment ratio (%) in Suriname in 2002?
Provide a succinct answer. -4.02. What is the difference between the Gross enrolment ratio (%) in Latin America(developing only) in 1990 and the Gross enrolment ratio (%) in Denmark in 2002?
Make the answer very short. -49.43. What is the difference between the Gross enrolment ratio (%) in Latin America(developing only) in 1990 and the Gross enrolment ratio (%) in Indonesia in 2002?
Provide a short and direct response. -0.9. What is the difference between the Gross enrolment ratio (%) of Latin America(developing only) in 1990 and the Gross enrolment ratio (%) of Suriname in 2002?
Keep it short and to the point. 2.03. What is the difference between the Gross enrolment ratio (%) in Denmark in 1990 and the Gross enrolment ratio (%) in Indonesia in 2002?
Your answer should be compact. 19.11. What is the difference between the Gross enrolment ratio (%) in Denmark in 1990 and the Gross enrolment ratio (%) in Suriname in 2002?
Offer a very short reply. 22.04. What is the difference between the Gross enrolment ratio (%) in Indonesia in 1990 and the Gross enrolment ratio (%) in Suriname in 2002?
Ensure brevity in your answer.  -3.57. What is the average Gross enrolment ratio (%) in Latin America(developing only) per year?
Provide a short and direct response. 15.38. What is the average Gross enrolment ratio (%) in Denmark per year?
Your response must be concise. 35.39. What is the average Gross enrolment ratio (%) in Indonesia per year?
Offer a very short reply. 8.43. What is the average Gross enrolment ratio (%) in Suriname per year?
Offer a very short reply. 8.87. In the year 1985, what is the difference between the Gross enrolment ratio (%) in Latin America(developing only) and Gross enrolment ratio (%) in Denmark?
Give a very brief answer. -13.25. In the year 1985, what is the difference between the Gross enrolment ratio (%) in Latin America(developing only) and Gross enrolment ratio (%) in Indonesia?
Make the answer very short. 9.35. In the year 1985, what is the difference between the Gross enrolment ratio (%) of Latin America(developing only) and Gross enrolment ratio (%) of Suriname?
Make the answer very short. 8.76. In the year 1985, what is the difference between the Gross enrolment ratio (%) in Denmark and Gross enrolment ratio (%) in Indonesia?
Provide a succinct answer. 22.6. In the year 1985, what is the difference between the Gross enrolment ratio (%) of Denmark and Gross enrolment ratio (%) of Suriname?
Keep it short and to the point. 22.01. In the year 1985, what is the difference between the Gross enrolment ratio (%) of Indonesia and Gross enrolment ratio (%) of Suriname?
Your answer should be compact. -0.59. In the year 1986, what is the difference between the Gross enrolment ratio (%) of Latin America(developing only) and Gross enrolment ratio (%) of Denmark?
Ensure brevity in your answer.  -15.41. In the year 1986, what is the difference between the Gross enrolment ratio (%) of Latin America(developing only) and Gross enrolment ratio (%) of Indonesia?
Your answer should be compact. 7.21. In the year 1986, what is the difference between the Gross enrolment ratio (%) of Latin America(developing only) and Gross enrolment ratio (%) of Suriname?
Ensure brevity in your answer.  7.24. In the year 1986, what is the difference between the Gross enrolment ratio (%) of Denmark and Gross enrolment ratio (%) of Indonesia?
Give a very brief answer. 22.62. In the year 1986, what is the difference between the Gross enrolment ratio (%) in Denmark and Gross enrolment ratio (%) in Suriname?
Keep it short and to the point. 22.64. In the year 1986, what is the difference between the Gross enrolment ratio (%) of Indonesia and Gross enrolment ratio (%) of Suriname?
Provide a succinct answer. 0.03. In the year 1987, what is the difference between the Gross enrolment ratio (%) of Latin America(developing only) and Gross enrolment ratio (%) of Denmark?
Offer a terse response. -15.75. In the year 1987, what is the difference between the Gross enrolment ratio (%) in Latin America(developing only) and Gross enrolment ratio (%) in Indonesia?
Your response must be concise. 6.17. In the year 1987, what is the difference between the Gross enrolment ratio (%) in Latin America(developing only) and Gross enrolment ratio (%) in Suriname?
Make the answer very short. 5.83. In the year 1987, what is the difference between the Gross enrolment ratio (%) in Denmark and Gross enrolment ratio (%) in Indonesia?
Your response must be concise. 21.92. In the year 1987, what is the difference between the Gross enrolment ratio (%) in Denmark and Gross enrolment ratio (%) in Suriname?
Your answer should be compact. 21.58. In the year 1987, what is the difference between the Gross enrolment ratio (%) in Indonesia and Gross enrolment ratio (%) in Suriname?
Keep it short and to the point. -0.34. In the year 1988, what is the difference between the Gross enrolment ratio (%) in Latin America(developing only) and Gross enrolment ratio (%) in Denmark?
Provide a succinct answer. -16.31. In the year 1988, what is the difference between the Gross enrolment ratio (%) of Latin America(developing only) and Gross enrolment ratio (%) of Indonesia?
Give a very brief answer. 7.33. In the year 1988, what is the difference between the Gross enrolment ratio (%) in Latin America(developing only) and Gross enrolment ratio (%) in Suriname?
Offer a very short reply. 5.56. In the year 1988, what is the difference between the Gross enrolment ratio (%) in Denmark and Gross enrolment ratio (%) in Indonesia?
Offer a very short reply. 23.64. In the year 1988, what is the difference between the Gross enrolment ratio (%) of Denmark and Gross enrolment ratio (%) of Suriname?
Your answer should be compact. 21.87. In the year 1988, what is the difference between the Gross enrolment ratio (%) of Indonesia and Gross enrolment ratio (%) of Suriname?
Give a very brief answer. -1.77. In the year 1989, what is the difference between the Gross enrolment ratio (%) in Latin America(developing only) and Gross enrolment ratio (%) in Denmark?
Give a very brief answer. -17.62. In the year 1989, what is the difference between the Gross enrolment ratio (%) of Latin America(developing only) and Gross enrolment ratio (%) of Indonesia?
Provide a short and direct response. 6.2. In the year 1989, what is the difference between the Gross enrolment ratio (%) in Latin America(developing only) and Gross enrolment ratio (%) in Suriname?
Ensure brevity in your answer.  4.66. In the year 1989, what is the difference between the Gross enrolment ratio (%) of Denmark and Gross enrolment ratio (%) of Indonesia?
Ensure brevity in your answer.  23.82. In the year 1989, what is the difference between the Gross enrolment ratio (%) of Denmark and Gross enrolment ratio (%) of Suriname?
Your answer should be compact. 22.28. In the year 1989, what is the difference between the Gross enrolment ratio (%) of Indonesia and Gross enrolment ratio (%) of Suriname?
Keep it short and to the point. -1.54. In the year 1990, what is the difference between the Gross enrolment ratio (%) of Latin America(developing only) and Gross enrolment ratio (%) of Denmark?
Keep it short and to the point. -20.01. In the year 1990, what is the difference between the Gross enrolment ratio (%) of Latin America(developing only) and Gross enrolment ratio (%) of Indonesia?
Offer a very short reply. 5.6. In the year 1990, what is the difference between the Gross enrolment ratio (%) in Latin America(developing only) and Gross enrolment ratio (%) in Suriname?
Provide a short and direct response. 3.77. In the year 1990, what is the difference between the Gross enrolment ratio (%) in Denmark and Gross enrolment ratio (%) in Indonesia?
Your answer should be very brief. 25.61. In the year 1990, what is the difference between the Gross enrolment ratio (%) of Denmark and Gross enrolment ratio (%) of Suriname?
Your response must be concise. 23.78. In the year 1990, what is the difference between the Gross enrolment ratio (%) of Indonesia and Gross enrolment ratio (%) of Suriname?
Offer a terse response. -1.83. In the year 2002, what is the difference between the Gross enrolment ratio (%) of Latin America(developing only) and Gross enrolment ratio (%) of Denmark?
Your answer should be compact. -41.74. In the year 2002, what is the difference between the Gross enrolment ratio (%) of Latin America(developing only) and Gross enrolment ratio (%) of Indonesia?
Provide a short and direct response. 6.79. In the year 2002, what is the difference between the Gross enrolment ratio (%) in Latin America(developing only) and Gross enrolment ratio (%) in Suriname?
Your response must be concise. 9.72. In the year 2002, what is the difference between the Gross enrolment ratio (%) in Denmark and Gross enrolment ratio (%) in Indonesia?
Give a very brief answer. 48.52. In the year 2002, what is the difference between the Gross enrolment ratio (%) of Denmark and Gross enrolment ratio (%) of Suriname?
Provide a succinct answer. 51.46. In the year 2002, what is the difference between the Gross enrolment ratio (%) of Indonesia and Gross enrolment ratio (%) of Suriname?
Your response must be concise. 2.93. What is the ratio of the Gross enrolment ratio (%) in Latin America(developing only) in 1985 to that in 1986?
Offer a very short reply. 1.14. What is the ratio of the Gross enrolment ratio (%) of Denmark in 1985 to that in 1986?
Offer a terse response. 0.99. What is the ratio of the Gross enrolment ratio (%) of Indonesia in 1985 to that in 1986?
Make the answer very short. 0.96. What is the ratio of the Gross enrolment ratio (%) in Suriname in 1985 to that in 1986?
Provide a short and direct response. 1.06. What is the ratio of the Gross enrolment ratio (%) of Latin America(developing only) in 1985 to that in 1987?
Your answer should be very brief. 1.12. What is the ratio of the Gross enrolment ratio (%) of Denmark in 1985 to that in 1987?
Give a very brief answer. 0.97. What is the ratio of the Gross enrolment ratio (%) of Indonesia in 1985 to that in 1987?
Keep it short and to the point. 0.81. What is the ratio of the Gross enrolment ratio (%) of Suriname in 1985 to that in 1987?
Give a very brief answer. 0.85. What is the ratio of the Gross enrolment ratio (%) in Latin America(developing only) in 1985 to that in 1988?
Offer a terse response. 1.09. What is the ratio of the Gross enrolment ratio (%) in Denmark in 1985 to that in 1988?
Your answer should be compact. 0.94. What is the ratio of the Gross enrolment ratio (%) in Indonesia in 1985 to that in 1988?
Your answer should be very brief. 0.89. What is the ratio of the Gross enrolment ratio (%) of Suriname in 1985 to that in 1988?
Keep it short and to the point. 0.78. What is the ratio of the Gross enrolment ratio (%) in Latin America(developing only) in 1985 to that in 1989?
Ensure brevity in your answer.  1.09. What is the ratio of the Gross enrolment ratio (%) of Denmark in 1985 to that in 1989?
Make the answer very short. 0.9. What is the ratio of the Gross enrolment ratio (%) in Indonesia in 1985 to that in 1989?
Offer a terse response. 0.77. What is the ratio of the Gross enrolment ratio (%) in Suriname in 1985 to that in 1989?
Your answer should be compact. 0.71. What is the ratio of the Gross enrolment ratio (%) in Latin America(developing only) in 1985 to that in 1990?
Provide a short and direct response. 1.1. What is the ratio of the Gross enrolment ratio (%) in Denmark in 1985 to that in 1990?
Provide a succinct answer. 0.85. What is the ratio of the Gross enrolment ratio (%) of Indonesia in 1985 to that in 1990?
Give a very brief answer. 0.73. What is the ratio of the Gross enrolment ratio (%) in Suriname in 1985 to that in 1990?
Your answer should be compact. 0.66. What is the ratio of the Gross enrolment ratio (%) in Latin America(developing only) in 1985 to that in 2002?
Your answer should be very brief. 0.72. What is the ratio of the Gross enrolment ratio (%) of Denmark in 1985 to that in 2002?
Your answer should be compact. 0.45. What is the ratio of the Gross enrolment ratio (%) in Indonesia in 1985 to that in 2002?
Provide a succinct answer. 0.42. What is the ratio of the Gross enrolment ratio (%) in Suriname in 1985 to that in 2002?
Your response must be concise. 0.57. What is the ratio of the Gross enrolment ratio (%) in Latin America(developing only) in 1986 to that in 1987?
Your response must be concise. 0.99. What is the ratio of the Gross enrolment ratio (%) in Denmark in 1986 to that in 1987?
Give a very brief answer. 0.98. What is the ratio of the Gross enrolment ratio (%) of Indonesia in 1986 to that in 1987?
Provide a succinct answer. 0.84. What is the ratio of the Gross enrolment ratio (%) in Suriname in 1986 to that in 1987?
Give a very brief answer. 0.8. What is the ratio of the Gross enrolment ratio (%) of Latin America(developing only) in 1986 to that in 1988?
Your answer should be very brief. 0.96. What is the ratio of the Gross enrolment ratio (%) of Denmark in 1986 to that in 1988?
Ensure brevity in your answer.  0.95. What is the ratio of the Gross enrolment ratio (%) in Indonesia in 1986 to that in 1988?
Your answer should be very brief. 0.93. What is the ratio of the Gross enrolment ratio (%) of Suriname in 1986 to that in 1988?
Offer a very short reply. 0.74. What is the ratio of the Gross enrolment ratio (%) of Latin America(developing only) in 1986 to that in 1989?
Your response must be concise. 0.96. What is the ratio of the Gross enrolment ratio (%) in Denmark in 1986 to that in 1989?
Provide a succinct answer. 0.91. What is the ratio of the Gross enrolment ratio (%) in Indonesia in 1986 to that in 1989?
Offer a very short reply. 0.81. What is the ratio of the Gross enrolment ratio (%) of Suriname in 1986 to that in 1989?
Offer a terse response. 0.67. What is the ratio of the Gross enrolment ratio (%) of Latin America(developing only) in 1986 to that in 1990?
Give a very brief answer. 0.97. What is the ratio of the Gross enrolment ratio (%) of Denmark in 1986 to that in 1990?
Provide a succinct answer. 0.85. What is the ratio of the Gross enrolment ratio (%) in Indonesia in 1986 to that in 1990?
Give a very brief answer. 0.76. What is the ratio of the Gross enrolment ratio (%) of Suriname in 1986 to that in 1990?
Make the answer very short. 0.63. What is the ratio of the Gross enrolment ratio (%) in Latin America(developing only) in 1986 to that in 2002?
Your answer should be very brief. 0.63. What is the ratio of the Gross enrolment ratio (%) in Denmark in 1986 to that in 2002?
Provide a short and direct response. 0.46. What is the ratio of the Gross enrolment ratio (%) in Indonesia in 1986 to that in 2002?
Ensure brevity in your answer.  0.43. What is the ratio of the Gross enrolment ratio (%) of Suriname in 1986 to that in 2002?
Keep it short and to the point. 0.54. What is the ratio of the Gross enrolment ratio (%) in Latin America(developing only) in 1987 to that in 1988?
Make the answer very short. 0.97. What is the ratio of the Gross enrolment ratio (%) of Indonesia in 1987 to that in 1988?
Provide a short and direct response. 1.11. What is the ratio of the Gross enrolment ratio (%) of Suriname in 1987 to that in 1988?
Your answer should be compact. 0.92. What is the ratio of the Gross enrolment ratio (%) in Latin America(developing only) in 1987 to that in 1989?
Your response must be concise. 0.97. What is the ratio of the Gross enrolment ratio (%) in Denmark in 1987 to that in 1989?
Your answer should be very brief. 0.93. What is the ratio of the Gross enrolment ratio (%) of Indonesia in 1987 to that in 1989?
Provide a short and direct response. 0.96. What is the ratio of the Gross enrolment ratio (%) of Suriname in 1987 to that in 1989?
Offer a very short reply. 0.84. What is the ratio of the Gross enrolment ratio (%) of Latin America(developing only) in 1987 to that in 1990?
Ensure brevity in your answer.  0.98. What is the ratio of the Gross enrolment ratio (%) of Denmark in 1987 to that in 1990?
Give a very brief answer. 0.87. What is the ratio of the Gross enrolment ratio (%) of Indonesia in 1987 to that in 1990?
Offer a terse response. 0.91. What is the ratio of the Gross enrolment ratio (%) of Suriname in 1987 to that in 1990?
Your answer should be compact. 0.78. What is the ratio of the Gross enrolment ratio (%) of Latin America(developing only) in 1987 to that in 2002?
Ensure brevity in your answer.  0.64. What is the ratio of the Gross enrolment ratio (%) of Denmark in 1987 to that in 2002?
Provide a succinct answer. 0.47. What is the ratio of the Gross enrolment ratio (%) in Indonesia in 1987 to that in 2002?
Provide a succinct answer. 0.51. What is the ratio of the Gross enrolment ratio (%) in Suriname in 1987 to that in 2002?
Keep it short and to the point. 0.67. What is the ratio of the Gross enrolment ratio (%) in Latin America(developing only) in 1988 to that in 1989?
Give a very brief answer. 1. What is the ratio of the Gross enrolment ratio (%) in Denmark in 1988 to that in 1989?
Offer a terse response. 0.96. What is the ratio of the Gross enrolment ratio (%) in Indonesia in 1988 to that in 1989?
Your answer should be very brief. 0.87. What is the ratio of the Gross enrolment ratio (%) of Suriname in 1988 to that in 1989?
Offer a terse response. 0.91. What is the ratio of the Gross enrolment ratio (%) in Latin America(developing only) in 1988 to that in 1990?
Offer a very short reply. 1.01. What is the ratio of the Gross enrolment ratio (%) of Denmark in 1988 to that in 1990?
Offer a very short reply. 0.9. What is the ratio of the Gross enrolment ratio (%) of Indonesia in 1988 to that in 1990?
Provide a succinct answer. 0.82. What is the ratio of the Gross enrolment ratio (%) in Suriname in 1988 to that in 1990?
Give a very brief answer. 0.85. What is the ratio of the Gross enrolment ratio (%) in Latin America(developing only) in 1988 to that in 2002?
Your answer should be compact. 0.66. What is the ratio of the Gross enrolment ratio (%) of Denmark in 1988 to that in 2002?
Your answer should be compact. 0.48. What is the ratio of the Gross enrolment ratio (%) of Indonesia in 1988 to that in 2002?
Offer a terse response. 0.46. What is the ratio of the Gross enrolment ratio (%) of Suriname in 1988 to that in 2002?
Offer a very short reply. 0.72. What is the ratio of the Gross enrolment ratio (%) of Latin America(developing only) in 1989 to that in 1990?
Your response must be concise. 1.01. What is the ratio of the Gross enrolment ratio (%) of Denmark in 1989 to that in 1990?
Ensure brevity in your answer.  0.93. What is the ratio of the Gross enrolment ratio (%) of Indonesia in 1989 to that in 1990?
Your answer should be compact. 0.95. What is the ratio of the Gross enrolment ratio (%) in Suriname in 1989 to that in 1990?
Give a very brief answer. 0.93. What is the ratio of the Gross enrolment ratio (%) in Latin America(developing only) in 1989 to that in 2002?
Offer a terse response. 0.65. What is the ratio of the Gross enrolment ratio (%) in Denmark in 1989 to that in 2002?
Keep it short and to the point. 0.5. What is the ratio of the Gross enrolment ratio (%) of Indonesia in 1989 to that in 2002?
Offer a very short reply. 0.54. What is the ratio of the Gross enrolment ratio (%) of Suriname in 1989 to that in 2002?
Keep it short and to the point. 0.79. What is the ratio of the Gross enrolment ratio (%) of Latin America(developing only) in 1990 to that in 2002?
Offer a very short reply. 0.65. What is the ratio of the Gross enrolment ratio (%) of Denmark in 1990 to that in 2002?
Offer a very short reply. 0.54. What is the ratio of the Gross enrolment ratio (%) in Indonesia in 1990 to that in 2002?
Provide a succinct answer. 0.57. What is the ratio of the Gross enrolment ratio (%) of Suriname in 1990 to that in 2002?
Give a very brief answer. 0.86. What is the difference between the highest and the second highest Gross enrolment ratio (%) in Latin America(developing only)?
Provide a short and direct response. 6.21. What is the difference between the highest and the second highest Gross enrolment ratio (%) of Denmark?
Offer a terse response. 29.41. What is the difference between the highest and the second highest Gross enrolment ratio (%) of Indonesia?
Provide a short and direct response. 6.5. What is the difference between the highest and the second highest Gross enrolment ratio (%) in Suriname?
Offer a terse response. 1.74. What is the difference between the highest and the lowest Gross enrolment ratio (%) in Latin America(developing only)?
Keep it short and to the point. 8.09. What is the difference between the highest and the lowest Gross enrolment ratio (%) of Denmark?
Provide a succinct answer. 34.7. What is the difference between the highest and the lowest Gross enrolment ratio (%) of Indonesia?
Give a very brief answer. 8.77. What is the difference between the highest and the lowest Gross enrolment ratio (%) in Suriname?
Keep it short and to the point. 5.61. 